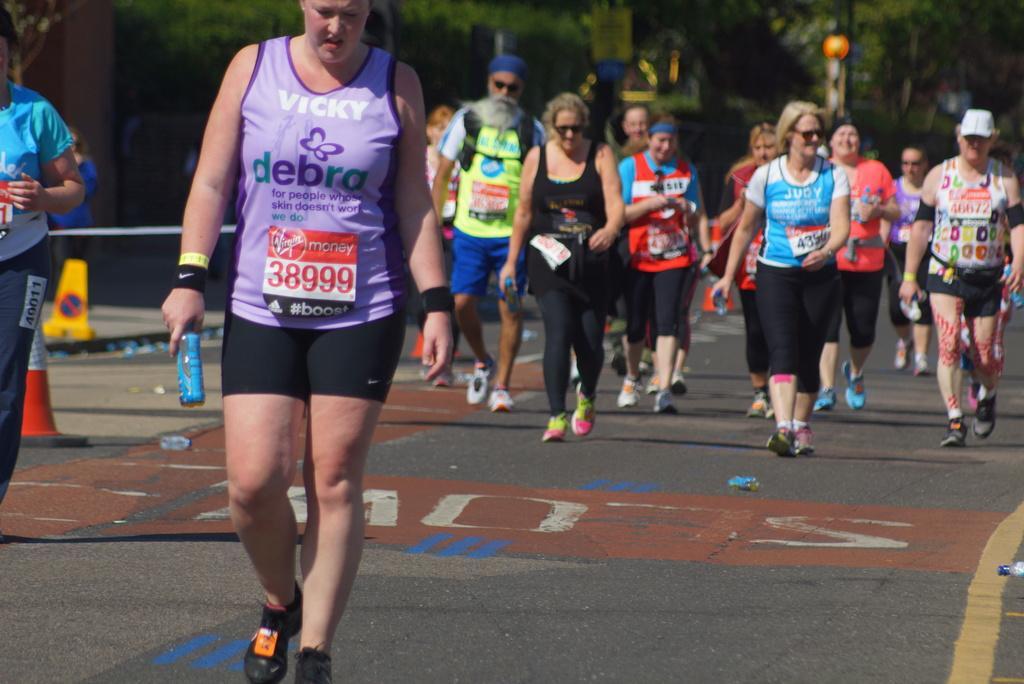How would you summarize this image in a sentence or two? In this picture we can see a few people holding objects and walking on the path. We can see some objects on the path. There is a traffic cone and a sign is visible on a board. We can see a few objects in the background. Background is blurry. 